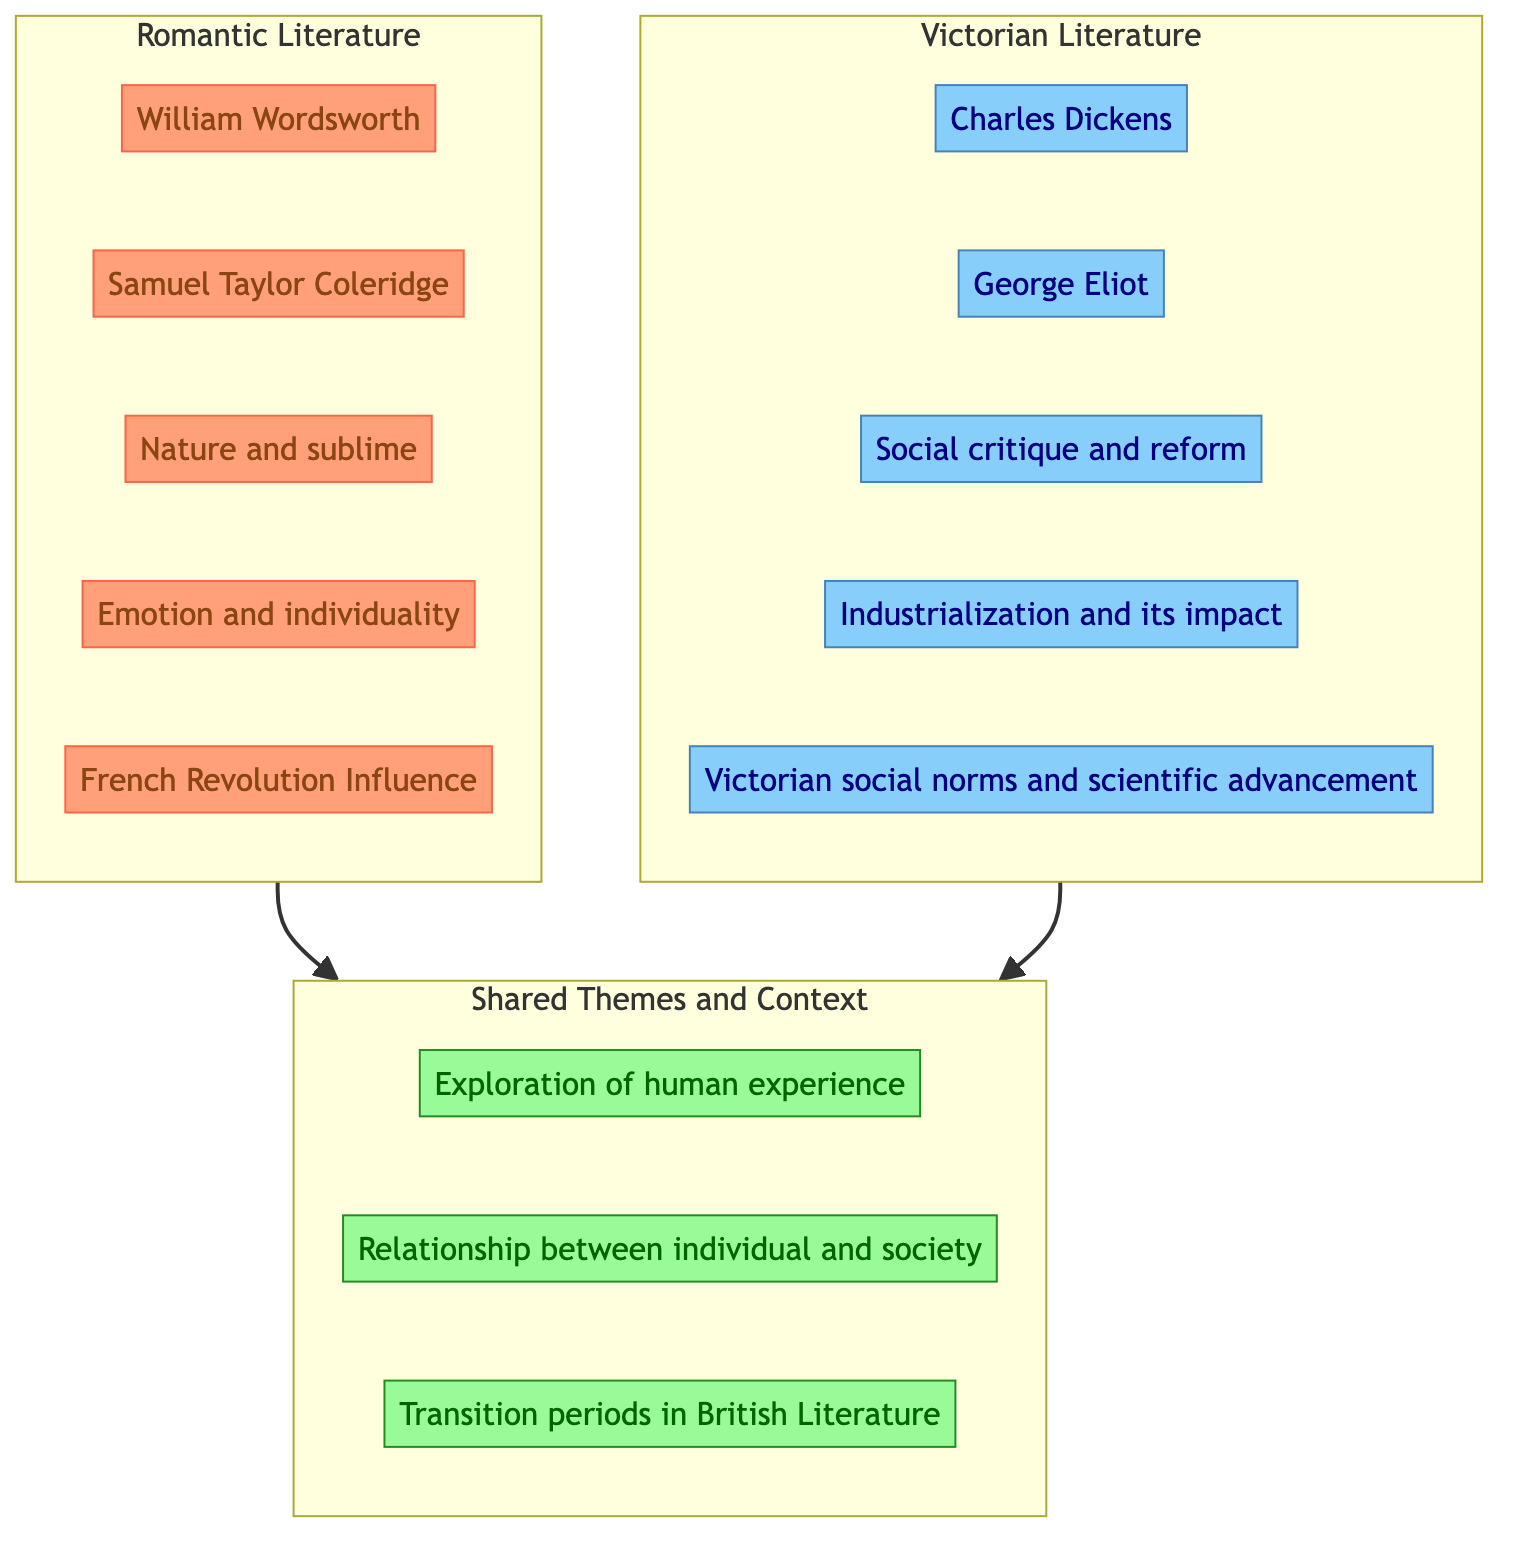What are two key authors of Romantic literature? The diagram lists William Wordsworth and Samuel Taylor Coleridge as the key authors of Romantic literature within the subgraph labeled "Romantic Literature".
Answer: William Wordsworth, Samuel Taylor Coleridge What theme is specifically associated with Victorian literature? The diagram highlights "Social critique and reform" as a distinguishing theme of Victorian literature, as it is placed exclusively in the "Victorian Literature" subgraph.
Answer: Social critique and reform How many shared themes are identified in the diagram? The diagram showcases three themes in the "Shared Themes and Context" subgraph, which can be counted directly.
Answer: 3 Which author is mentioned in both the Romantic and Victorian literature sections? The diagram does not provide an author that appears in both sections; it distinctly categorizes authors into the Romantic or Victorian groups without overlap.
Answer: None What historical influence is noted in the Romantic section? The diagram specifically lists "French Revolution Influence" as a prominent influence on Romantic literature, found within the subgraph for Romantic Literature.
Answer: French Revolution Influence How do Romantic and Victorian literature relate to human experience? Both literary movements explore "Exploration of human experience" as a shared theme, which is indicated in the shared space connecting both subgraphs.
Answer: Exploration of human experience Which literary movement focuses on industrialization? The diagram clearly categorizes "Industrialization and its impact" under the Victorian literature section, indicating its relevance to that movement.
Answer: Victorian literature How many authors are in the Victorian literature section? The Victorian literature section lists three distinct authors: Charles Dickens and George Eliot, which can be counted directly from the diagram.
Answer: 3 Which theme indicates a transition period in British literature? The diagram includes "Transition periods in British Literature" as a shared theme, connecting both Romantic and Victorian literature, which suggests its importance.
Answer: Transition periods in British Literature 